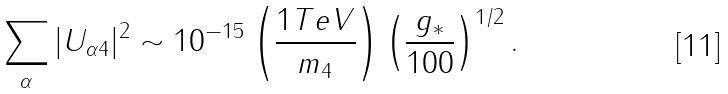Convert formula to latex. <formula><loc_0><loc_0><loc_500><loc_500>\sum _ { \alpha } | U _ { \alpha 4 } | ^ { 2 } \sim 1 0 ^ { - 1 5 } \left ( \frac { 1 T e V } { m _ { 4 } } \right ) \left ( \frac { g _ { * } } { 1 0 0 } \right ) ^ { 1 / 2 } .</formula> 